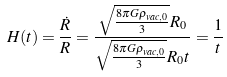<formula> <loc_0><loc_0><loc_500><loc_500>H ( t ) = \frac { \dot { R } } { R } = \frac { \sqrt { \frac { 8 \pi G \rho _ { v a c , 0 } } { 3 } } R _ { 0 } } { \sqrt { \frac { 8 \pi G \rho _ { v a c , 0 } } { 3 } } R _ { 0 } t } = \frac { 1 } { t }</formula> 